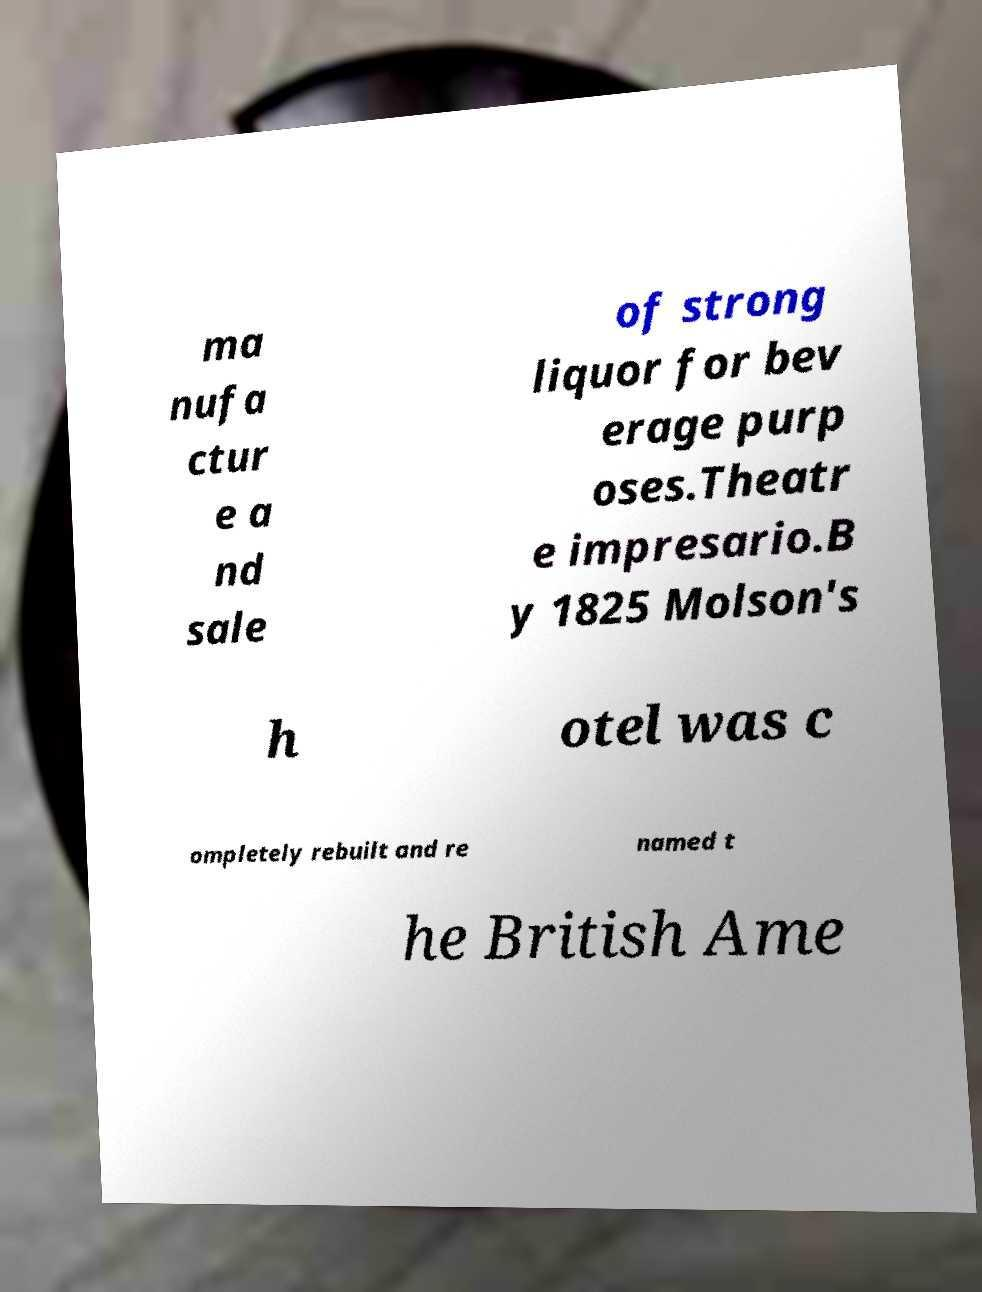For documentation purposes, I need the text within this image transcribed. Could you provide that? ma nufa ctur e a nd sale of strong liquor for bev erage purp oses.Theatr e impresario.B y 1825 Molson's h otel was c ompletely rebuilt and re named t he British Ame 